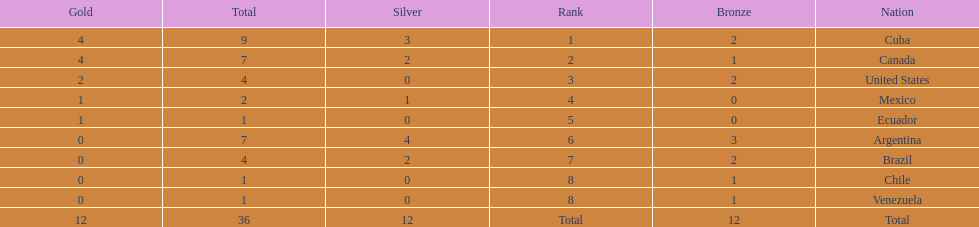How many total medals did brazil received? 4. 